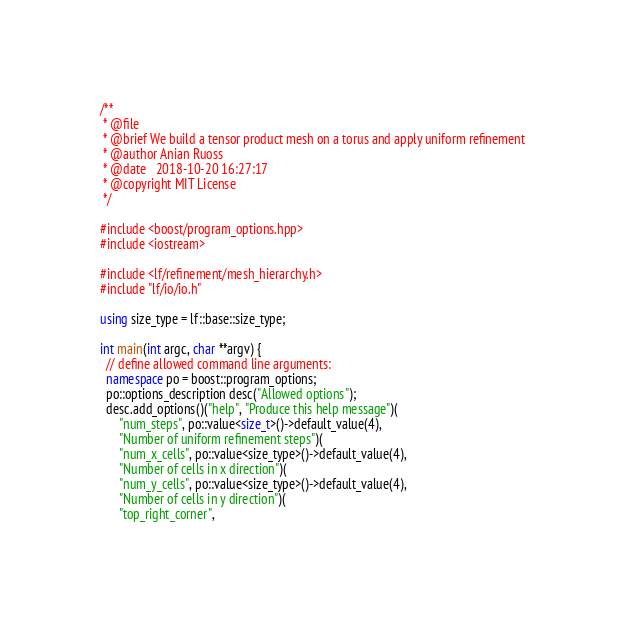Convert code to text. <code><loc_0><loc_0><loc_500><loc_500><_C++_>/**
 * @file
 * @brief We build a tensor product mesh on a torus and apply uniform refinement
 * @author Anian Ruoss
 * @date   2018-10-20 16:27:17
 * @copyright MIT License
 */

#include <boost/program_options.hpp>
#include <iostream>

#include <lf/refinement/mesh_hierarchy.h>
#include "lf/io/io.h"

using size_type = lf::base::size_type;

int main(int argc, char **argv) {
  // define allowed command line arguments:
  namespace po = boost::program_options;
  po::options_description desc("Allowed options");
  desc.add_options()("help", "Produce this help message")(
      "num_steps", po::value<size_t>()->default_value(4),
      "Number of uniform refinement steps")(
      "num_x_cells", po::value<size_type>()->default_value(4),
      "Number of cells in x direction")(
      "num_y_cells", po::value<size_type>()->default_value(4),
      "Number of cells in y direction")(
      "top_right_corner",</code> 